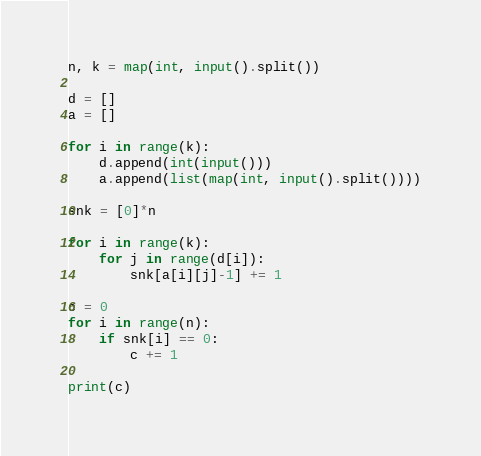<code> <loc_0><loc_0><loc_500><loc_500><_Python_>n, k = map(int, input().split())

d = []
a = []

for i in range(k):
	d.append(int(input()))
	a.append(list(map(int, input().split())))

snk = [0]*n

for i in range(k):
	for j in range(d[i]):
		snk[a[i][j]-1] += 1

c = 0
for i in range(n):
	if snk[i] == 0:
		c += 1

print(c)</code> 